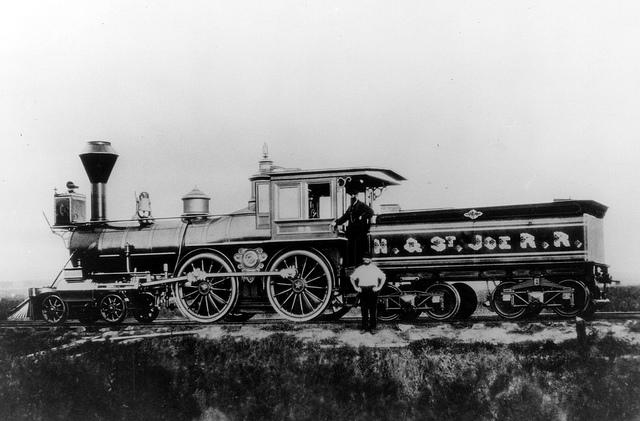How many people are in the picture?
Give a very brief answer. 2. What is train hauling?
Keep it brief. Nothing. What object is the focal point of the image?
Give a very brief answer. Train. How many colors are in the picture?
Quick response, please. 2. 